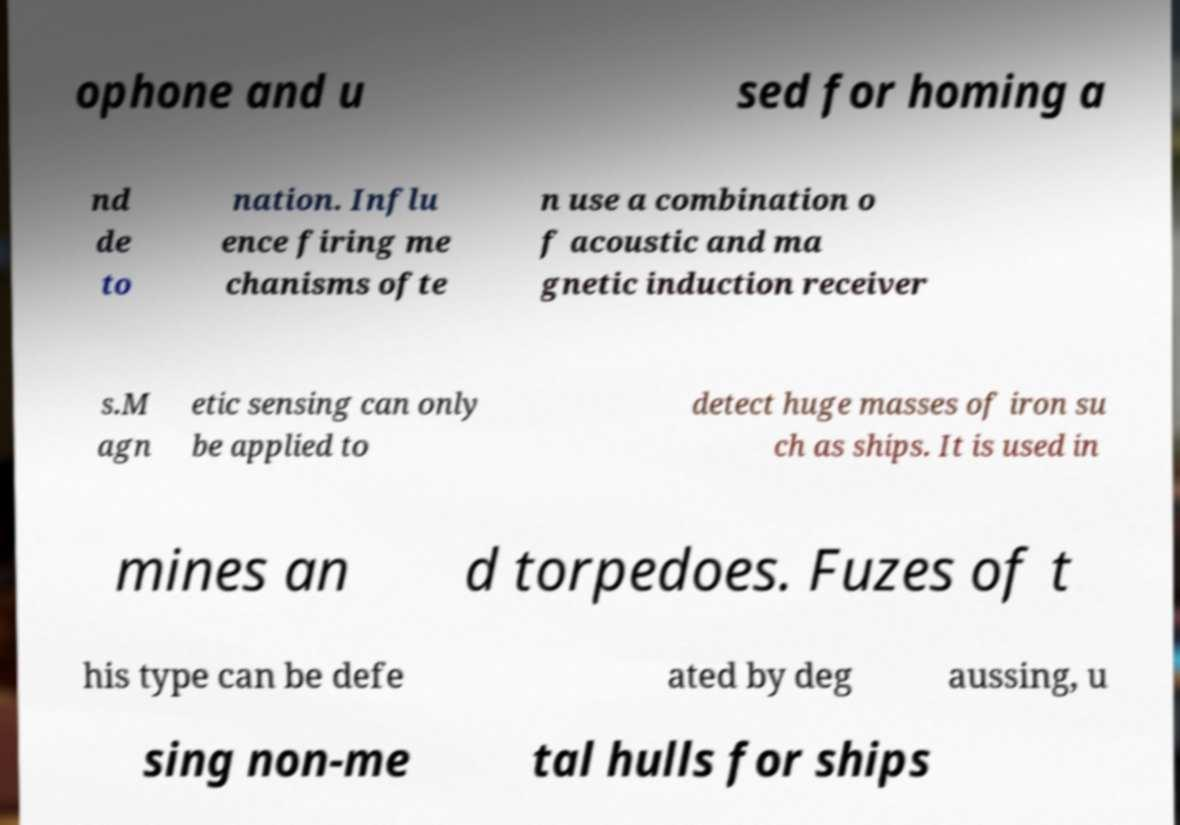Please read and relay the text visible in this image. What does it say? ophone and u sed for homing a nd de to nation. Influ ence firing me chanisms ofte n use a combination o f acoustic and ma gnetic induction receiver s.M agn etic sensing can only be applied to detect huge masses of iron su ch as ships. It is used in mines an d torpedoes. Fuzes of t his type can be defe ated by deg aussing, u sing non-me tal hulls for ships 